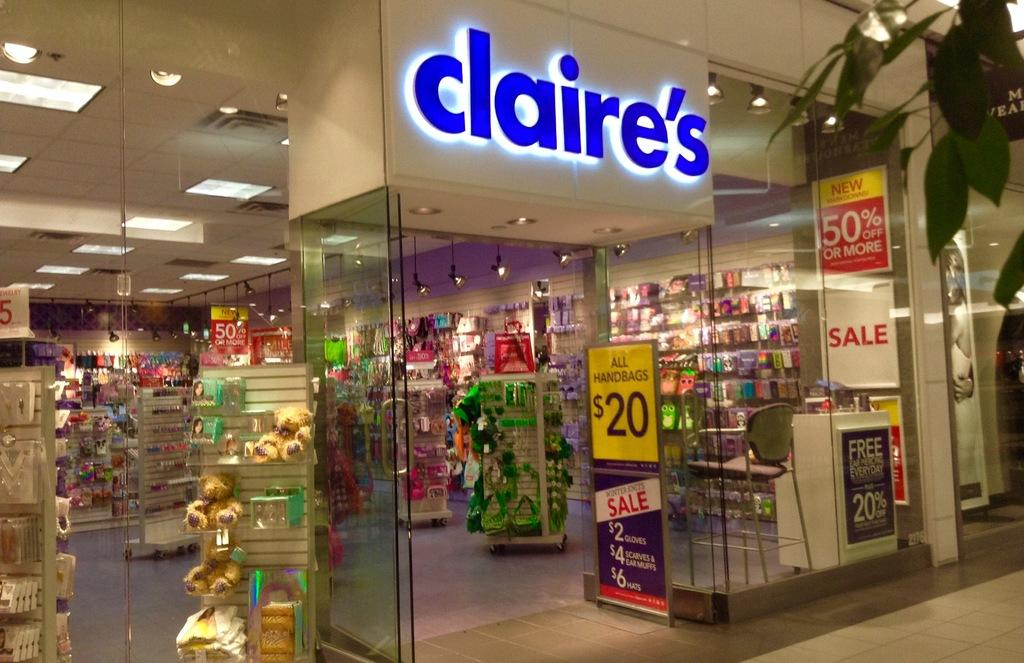<image>
Give a short and clear explanation of the subsequent image. The front of a store called Claire, with Claire spelled in blue letters. 